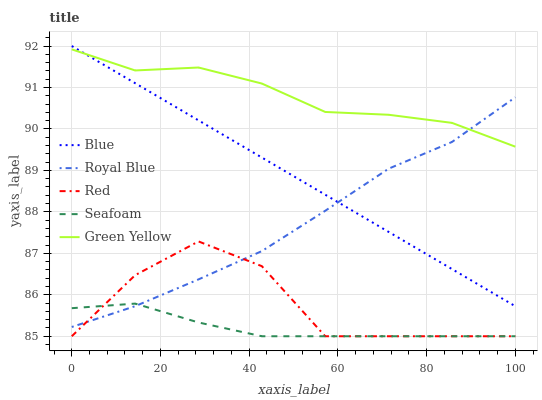Does Seafoam have the minimum area under the curve?
Answer yes or no. Yes. Does Green Yellow have the maximum area under the curve?
Answer yes or no. Yes. Does Royal Blue have the minimum area under the curve?
Answer yes or no. No. Does Royal Blue have the maximum area under the curve?
Answer yes or no. No. Is Blue the smoothest?
Answer yes or no. Yes. Is Red the roughest?
Answer yes or no. Yes. Is Royal Blue the smoothest?
Answer yes or no. No. Is Royal Blue the roughest?
Answer yes or no. No. Does Seafoam have the lowest value?
Answer yes or no. Yes. Does Royal Blue have the lowest value?
Answer yes or no. No. Does Blue have the highest value?
Answer yes or no. Yes. Does Royal Blue have the highest value?
Answer yes or no. No. Is Red less than Green Yellow?
Answer yes or no. Yes. Is Green Yellow greater than Seafoam?
Answer yes or no. Yes. Does Seafoam intersect Red?
Answer yes or no. Yes. Is Seafoam less than Red?
Answer yes or no. No. Is Seafoam greater than Red?
Answer yes or no. No. Does Red intersect Green Yellow?
Answer yes or no. No. 